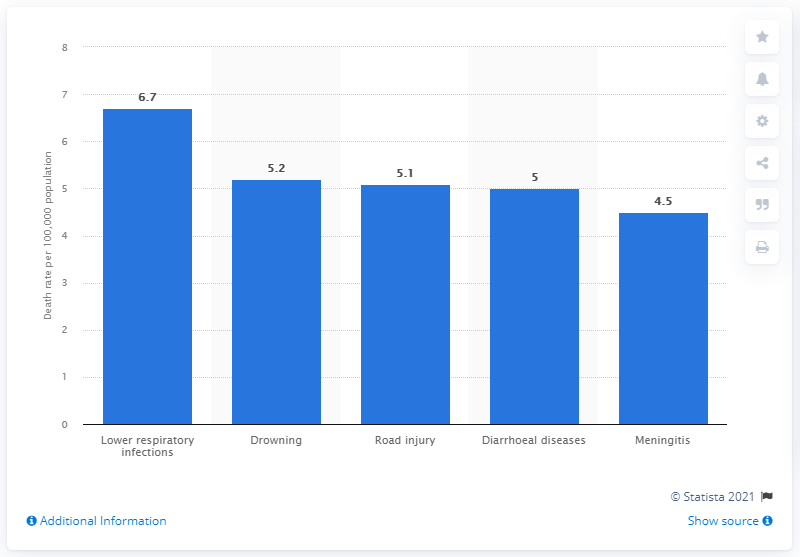Identify some key points in this picture. Lower respiratory infections are the leading cause of death among adolescents aged 10 to 14 years. 